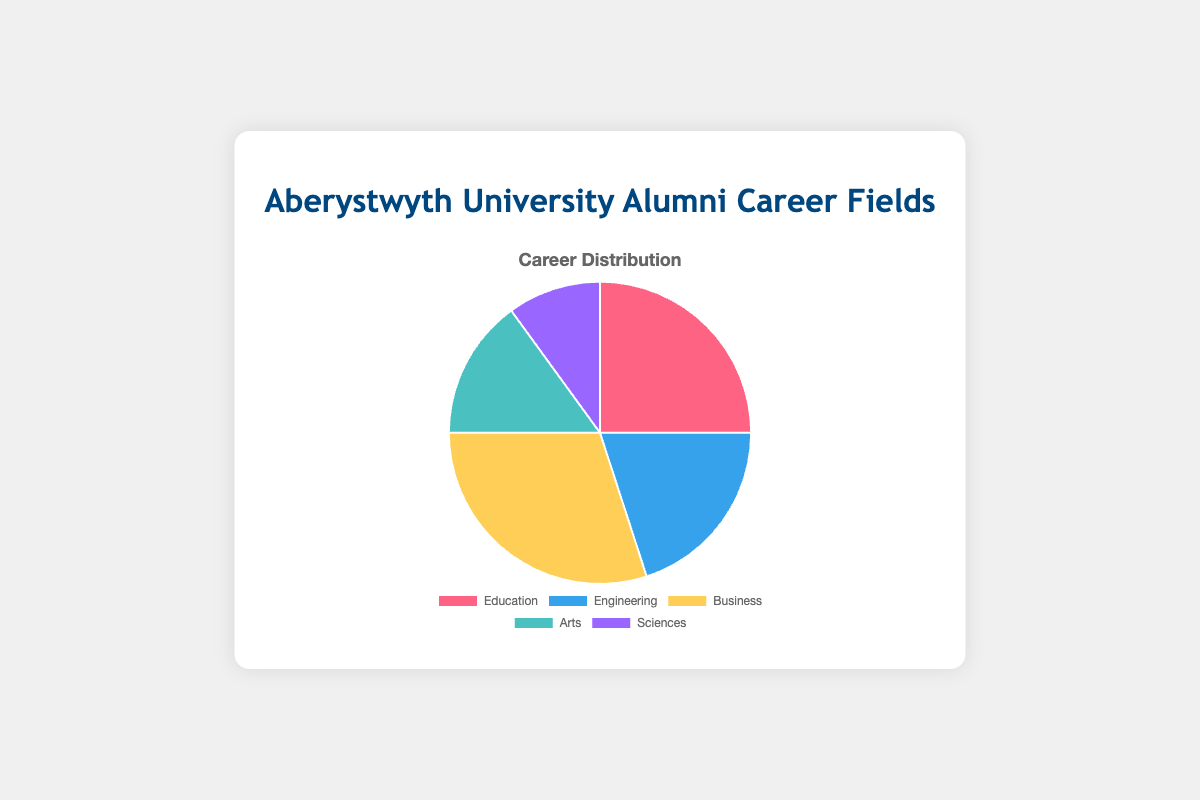How many alumni work in the Sciences and Arts fields combined? To find the total number of alumni in the Sciences and Arts fields, add the number of alumni in each field. There are 10 alumni in Sciences and 15 in Arts. Thus, 10 + 15 = 25
Answer: 25 What percentage of alumni work in Education? To find the percentage, divide the number of alumni in Education by the total number of alumni and multiply by 100. There are 25 alumni in Education and a total of 100 alumni. So, (25/100) * 100 = 25%
Answer: 25% Which field has the lowest number of alumni? By examining the data, we see that Sciences have the lowest number of alumni with 10
Answer: Sciences How does the number of alumni in Business compare to the number in Engineering? To compare, we look at the numbers: Business has 30 alumni and Engineering has 20. Therefore, Business has 10 more alumni than Engineering
Answer: Business has 10 more What is the difference between the number of alumni in Arts and Education? Subtract the number of alumni in Arts from those in Education. Education has 25 alumni and Arts has 15. Thus, 25 - 15 = 10
Answer: 10 Which is the second most popular career field among alumni? By ranking the fields by number of alumni, Business is highest with 30, followed by Education with 25. Therefore, Education is the second most popular field
Answer: Education Is the combined number of alumni in Engineering and Arts greater than the number of alumni in Business? Combine the number of alumni in Engineering and Arts: 20 (Engineering) + 15 (Arts) = 35. Since Business has 30, 35 is greater than 30
Answer: Yes, it is Which color represents the field with the highest number of alumni? In the pie chart, Business is the field with the highest number of alumni, and it is represented by the color yellow
Answer: Yellow If you combine the three fields with the highest number of alumni, what is the total? Identify the top three fields: Business (30), Education (25), and Engineering (20). Sum these numbers: 30 + 25 + 20 = 75
Answer: 75 What is the ratio of alumni in Education to Engineering? To find the ratio, divide the number of alumni in Education by the number in Engineering. There are 25 alumni in Education and 20 in Engineering, so the ratio is 25:20, which simplifies to 5:4
Answer: 5:4 